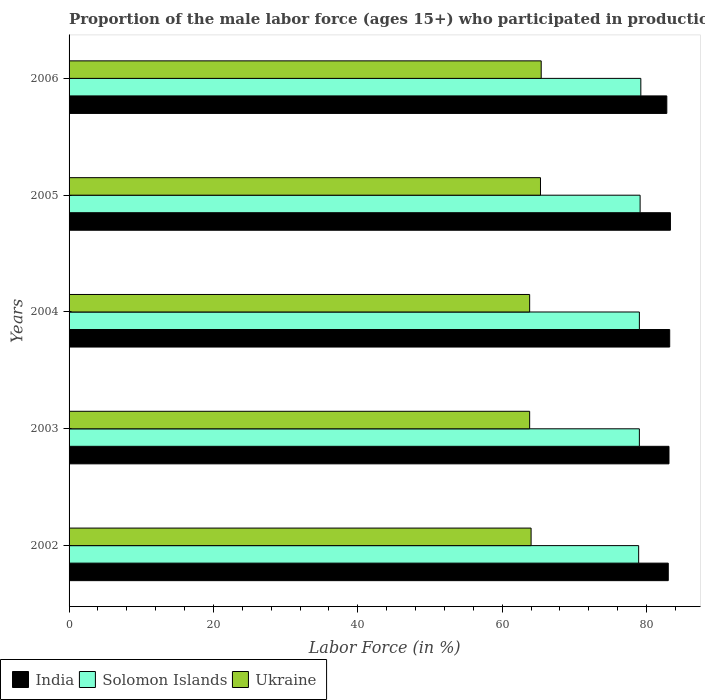How many different coloured bars are there?
Offer a very short reply. 3. How many groups of bars are there?
Your response must be concise. 5. Are the number of bars on each tick of the Y-axis equal?
Ensure brevity in your answer.  Yes. How many bars are there on the 1st tick from the top?
Provide a succinct answer. 3. What is the proportion of the male labor force who participated in production in India in 2005?
Offer a very short reply. 83.3. Across all years, what is the maximum proportion of the male labor force who participated in production in Ukraine?
Your answer should be compact. 65.4. Across all years, what is the minimum proportion of the male labor force who participated in production in India?
Give a very brief answer. 82.8. In which year was the proportion of the male labor force who participated in production in India maximum?
Give a very brief answer. 2005. What is the total proportion of the male labor force who participated in production in India in the graph?
Provide a short and direct response. 415.4. What is the difference between the proportion of the male labor force who participated in production in Ukraine in 2002 and that in 2006?
Offer a very short reply. -1.4. What is the difference between the proportion of the male labor force who participated in production in India in 2004 and the proportion of the male labor force who participated in production in Solomon Islands in 2005?
Your answer should be very brief. 4.1. What is the average proportion of the male labor force who participated in production in Ukraine per year?
Your response must be concise. 64.46. What is the ratio of the proportion of the male labor force who participated in production in Ukraine in 2002 to that in 2005?
Give a very brief answer. 0.98. What is the difference between the highest and the second highest proportion of the male labor force who participated in production in India?
Your answer should be very brief. 0.1. Is the sum of the proportion of the male labor force who participated in production in India in 2005 and 2006 greater than the maximum proportion of the male labor force who participated in production in Solomon Islands across all years?
Offer a very short reply. Yes. What does the 3rd bar from the top in 2005 represents?
Offer a very short reply. India. What does the 3rd bar from the bottom in 2005 represents?
Your answer should be compact. Ukraine. Is it the case that in every year, the sum of the proportion of the male labor force who participated in production in India and proportion of the male labor force who participated in production in Ukraine is greater than the proportion of the male labor force who participated in production in Solomon Islands?
Provide a succinct answer. Yes. How many years are there in the graph?
Offer a very short reply. 5. What is the difference between two consecutive major ticks on the X-axis?
Give a very brief answer. 20. Are the values on the major ticks of X-axis written in scientific E-notation?
Make the answer very short. No. How many legend labels are there?
Keep it short and to the point. 3. How are the legend labels stacked?
Your answer should be compact. Horizontal. What is the title of the graph?
Make the answer very short. Proportion of the male labor force (ages 15+) who participated in production. What is the label or title of the Y-axis?
Keep it short and to the point. Years. What is the Labor Force (in %) in India in 2002?
Provide a succinct answer. 83. What is the Labor Force (in %) of Solomon Islands in 2002?
Offer a terse response. 78.9. What is the Labor Force (in %) in Ukraine in 2002?
Provide a succinct answer. 64. What is the Labor Force (in %) of India in 2003?
Your response must be concise. 83.1. What is the Labor Force (in %) in Solomon Islands in 2003?
Give a very brief answer. 79. What is the Labor Force (in %) of Ukraine in 2003?
Provide a short and direct response. 63.8. What is the Labor Force (in %) in India in 2004?
Your answer should be very brief. 83.2. What is the Labor Force (in %) in Solomon Islands in 2004?
Provide a short and direct response. 79. What is the Labor Force (in %) in Ukraine in 2004?
Your response must be concise. 63.8. What is the Labor Force (in %) of India in 2005?
Provide a succinct answer. 83.3. What is the Labor Force (in %) in Solomon Islands in 2005?
Your answer should be very brief. 79.1. What is the Labor Force (in %) in Ukraine in 2005?
Your answer should be very brief. 65.3. What is the Labor Force (in %) in India in 2006?
Keep it short and to the point. 82.8. What is the Labor Force (in %) of Solomon Islands in 2006?
Your answer should be very brief. 79.2. What is the Labor Force (in %) of Ukraine in 2006?
Keep it short and to the point. 65.4. Across all years, what is the maximum Labor Force (in %) of India?
Give a very brief answer. 83.3. Across all years, what is the maximum Labor Force (in %) of Solomon Islands?
Offer a terse response. 79.2. Across all years, what is the maximum Labor Force (in %) of Ukraine?
Make the answer very short. 65.4. Across all years, what is the minimum Labor Force (in %) in India?
Make the answer very short. 82.8. Across all years, what is the minimum Labor Force (in %) of Solomon Islands?
Your answer should be compact. 78.9. Across all years, what is the minimum Labor Force (in %) in Ukraine?
Give a very brief answer. 63.8. What is the total Labor Force (in %) of India in the graph?
Your response must be concise. 415.4. What is the total Labor Force (in %) of Solomon Islands in the graph?
Give a very brief answer. 395.2. What is the total Labor Force (in %) in Ukraine in the graph?
Your answer should be compact. 322.3. What is the difference between the Labor Force (in %) in India in 2002 and that in 2004?
Offer a terse response. -0.2. What is the difference between the Labor Force (in %) in Solomon Islands in 2002 and that in 2006?
Your answer should be very brief. -0.3. What is the difference between the Labor Force (in %) in Ukraine in 2002 and that in 2006?
Your answer should be compact. -1.4. What is the difference between the Labor Force (in %) in Solomon Islands in 2003 and that in 2004?
Ensure brevity in your answer.  0. What is the difference between the Labor Force (in %) of Ukraine in 2003 and that in 2004?
Keep it short and to the point. 0. What is the difference between the Labor Force (in %) in Ukraine in 2003 and that in 2005?
Your response must be concise. -1.5. What is the difference between the Labor Force (in %) in Ukraine in 2003 and that in 2006?
Provide a short and direct response. -1.6. What is the difference between the Labor Force (in %) of India in 2004 and that in 2005?
Provide a succinct answer. -0.1. What is the difference between the Labor Force (in %) of Solomon Islands in 2004 and that in 2005?
Your answer should be very brief. -0.1. What is the difference between the Labor Force (in %) in Solomon Islands in 2004 and that in 2006?
Keep it short and to the point. -0.2. What is the difference between the Labor Force (in %) in Ukraine in 2004 and that in 2006?
Provide a short and direct response. -1.6. What is the difference between the Labor Force (in %) in India in 2005 and that in 2006?
Your answer should be compact. 0.5. What is the difference between the Labor Force (in %) in India in 2002 and the Labor Force (in %) in Solomon Islands in 2003?
Make the answer very short. 4. What is the difference between the Labor Force (in %) in India in 2002 and the Labor Force (in %) in Ukraine in 2003?
Your answer should be compact. 19.2. What is the difference between the Labor Force (in %) of Solomon Islands in 2002 and the Labor Force (in %) of Ukraine in 2003?
Provide a short and direct response. 15.1. What is the difference between the Labor Force (in %) of Solomon Islands in 2002 and the Labor Force (in %) of Ukraine in 2004?
Your answer should be compact. 15.1. What is the difference between the Labor Force (in %) in India in 2002 and the Labor Force (in %) in Solomon Islands in 2005?
Offer a terse response. 3.9. What is the difference between the Labor Force (in %) in Solomon Islands in 2002 and the Labor Force (in %) in Ukraine in 2005?
Offer a very short reply. 13.6. What is the difference between the Labor Force (in %) of India in 2002 and the Labor Force (in %) of Solomon Islands in 2006?
Your answer should be compact. 3.8. What is the difference between the Labor Force (in %) in India in 2003 and the Labor Force (in %) in Solomon Islands in 2004?
Offer a terse response. 4.1. What is the difference between the Labor Force (in %) of India in 2003 and the Labor Force (in %) of Ukraine in 2004?
Make the answer very short. 19.3. What is the difference between the Labor Force (in %) in Solomon Islands in 2003 and the Labor Force (in %) in Ukraine in 2005?
Your answer should be compact. 13.7. What is the difference between the Labor Force (in %) of Solomon Islands in 2003 and the Labor Force (in %) of Ukraine in 2006?
Your answer should be compact. 13.6. What is the difference between the Labor Force (in %) in India in 2004 and the Labor Force (in %) in Solomon Islands in 2005?
Ensure brevity in your answer.  4.1. What is the difference between the Labor Force (in %) in India in 2004 and the Labor Force (in %) in Solomon Islands in 2006?
Give a very brief answer. 4. What is the difference between the Labor Force (in %) in India in 2004 and the Labor Force (in %) in Ukraine in 2006?
Offer a terse response. 17.8. What is the difference between the Labor Force (in %) in Solomon Islands in 2004 and the Labor Force (in %) in Ukraine in 2006?
Offer a very short reply. 13.6. What is the difference between the Labor Force (in %) in India in 2005 and the Labor Force (in %) in Solomon Islands in 2006?
Your answer should be compact. 4.1. What is the difference between the Labor Force (in %) of Solomon Islands in 2005 and the Labor Force (in %) of Ukraine in 2006?
Offer a very short reply. 13.7. What is the average Labor Force (in %) in India per year?
Keep it short and to the point. 83.08. What is the average Labor Force (in %) in Solomon Islands per year?
Your answer should be very brief. 79.04. What is the average Labor Force (in %) in Ukraine per year?
Offer a very short reply. 64.46. In the year 2002, what is the difference between the Labor Force (in %) in India and Labor Force (in %) in Solomon Islands?
Your answer should be very brief. 4.1. In the year 2003, what is the difference between the Labor Force (in %) in India and Labor Force (in %) in Solomon Islands?
Keep it short and to the point. 4.1. In the year 2003, what is the difference between the Labor Force (in %) of India and Labor Force (in %) of Ukraine?
Your answer should be compact. 19.3. In the year 2003, what is the difference between the Labor Force (in %) in Solomon Islands and Labor Force (in %) in Ukraine?
Your answer should be compact. 15.2. In the year 2004, what is the difference between the Labor Force (in %) of India and Labor Force (in %) of Solomon Islands?
Keep it short and to the point. 4.2. In the year 2004, what is the difference between the Labor Force (in %) in India and Labor Force (in %) in Ukraine?
Your response must be concise. 19.4. In the year 2004, what is the difference between the Labor Force (in %) in Solomon Islands and Labor Force (in %) in Ukraine?
Your answer should be very brief. 15.2. In the year 2005, what is the difference between the Labor Force (in %) of India and Labor Force (in %) of Solomon Islands?
Offer a very short reply. 4.2. In the year 2005, what is the difference between the Labor Force (in %) in India and Labor Force (in %) in Ukraine?
Your response must be concise. 18. In the year 2005, what is the difference between the Labor Force (in %) in Solomon Islands and Labor Force (in %) in Ukraine?
Ensure brevity in your answer.  13.8. What is the ratio of the Labor Force (in %) in India in 2002 to that in 2003?
Ensure brevity in your answer.  1. What is the ratio of the Labor Force (in %) of Solomon Islands in 2002 to that in 2003?
Give a very brief answer. 1. What is the ratio of the Labor Force (in %) of Ukraine in 2002 to that in 2003?
Offer a very short reply. 1. What is the ratio of the Labor Force (in %) in India in 2002 to that in 2004?
Provide a short and direct response. 1. What is the ratio of the Labor Force (in %) in Solomon Islands in 2002 to that in 2004?
Keep it short and to the point. 1. What is the ratio of the Labor Force (in %) in India in 2002 to that in 2005?
Offer a very short reply. 1. What is the ratio of the Labor Force (in %) in Ukraine in 2002 to that in 2005?
Ensure brevity in your answer.  0.98. What is the ratio of the Labor Force (in %) in Ukraine in 2002 to that in 2006?
Give a very brief answer. 0.98. What is the ratio of the Labor Force (in %) in India in 2003 to that in 2004?
Make the answer very short. 1. What is the ratio of the Labor Force (in %) of Ukraine in 2003 to that in 2004?
Provide a short and direct response. 1. What is the ratio of the Labor Force (in %) of India in 2003 to that in 2005?
Keep it short and to the point. 1. What is the ratio of the Labor Force (in %) of Solomon Islands in 2003 to that in 2005?
Give a very brief answer. 1. What is the ratio of the Labor Force (in %) of Ukraine in 2003 to that in 2005?
Your answer should be very brief. 0.98. What is the ratio of the Labor Force (in %) of Solomon Islands in 2003 to that in 2006?
Offer a terse response. 1. What is the ratio of the Labor Force (in %) of Ukraine in 2003 to that in 2006?
Ensure brevity in your answer.  0.98. What is the ratio of the Labor Force (in %) of India in 2004 to that in 2005?
Give a very brief answer. 1. What is the ratio of the Labor Force (in %) of Solomon Islands in 2004 to that in 2005?
Provide a succinct answer. 1. What is the ratio of the Labor Force (in %) in India in 2004 to that in 2006?
Offer a terse response. 1. What is the ratio of the Labor Force (in %) of Ukraine in 2004 to that in 2006?
Give a very brief answer. 0.98. What is the ratio of the Labor Force (in %) in Solomon Islands in 2005 to that in 2006?
Keep it short and to the point. 1. What is the difference between the highest and the second highest Labor Force (in %) in India?
Keep it short and to the point. 0.1. What is the difference between the highest and the second highest Labor Force (in %) in Ukraine?
Your answer should be very brief. 0.1. What is the difference between the highest and the lowest Labor Force (in %) in Solomon Islands?
Your answer should be compact. 0.3. What is the difference between the highest and the lowest Labor Force (in %) of Ukraine?
Keep it short and to the point. 1.6. 